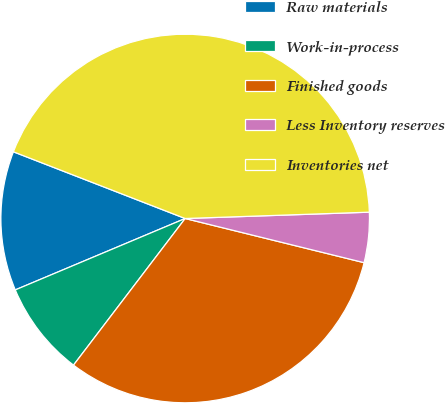Convert chart to OTSL. <chart><loc_0><loc_0><loc_500><loc_500><pie_chart><fcel>Raw materials<fcel>Work-in-process<fcel>Finished goods<fcel>Less Inventory reserves<fcel>Inventories net<nl><fcel>12.23%<fcel>8.31%<fcel>31.51%<fcel>4.4%<fcel>43.56%<nl></chart> 